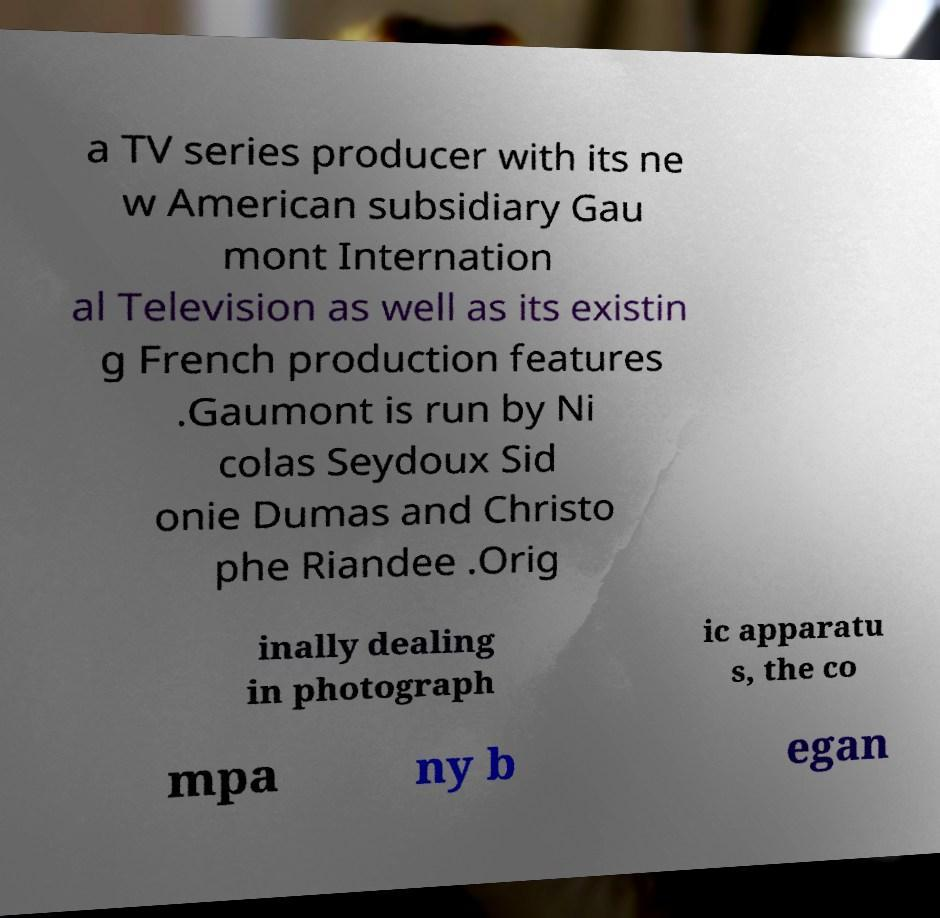Can you accurately transcribe the text from the provided image for me? a TV series producer with its ne w American subsidiary Gau mont Internation al Television as well as its existin g French production features .Gaumont is run by Ni colas Seydoux Sid onie Dumas and Christo phe Riandee .Orig inally dealing in photograph ic apparatu s, the co mpa ny b egan 